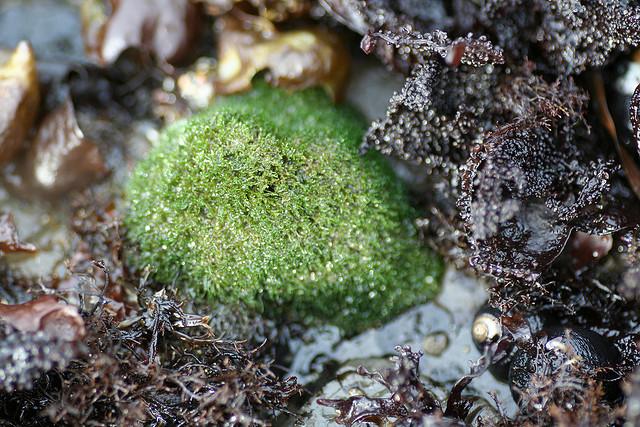What is green?
Concise answer only. Moss. Is this underwater?
Short answer required. No. Are the plants live?
Write a very short answer. Yes. 